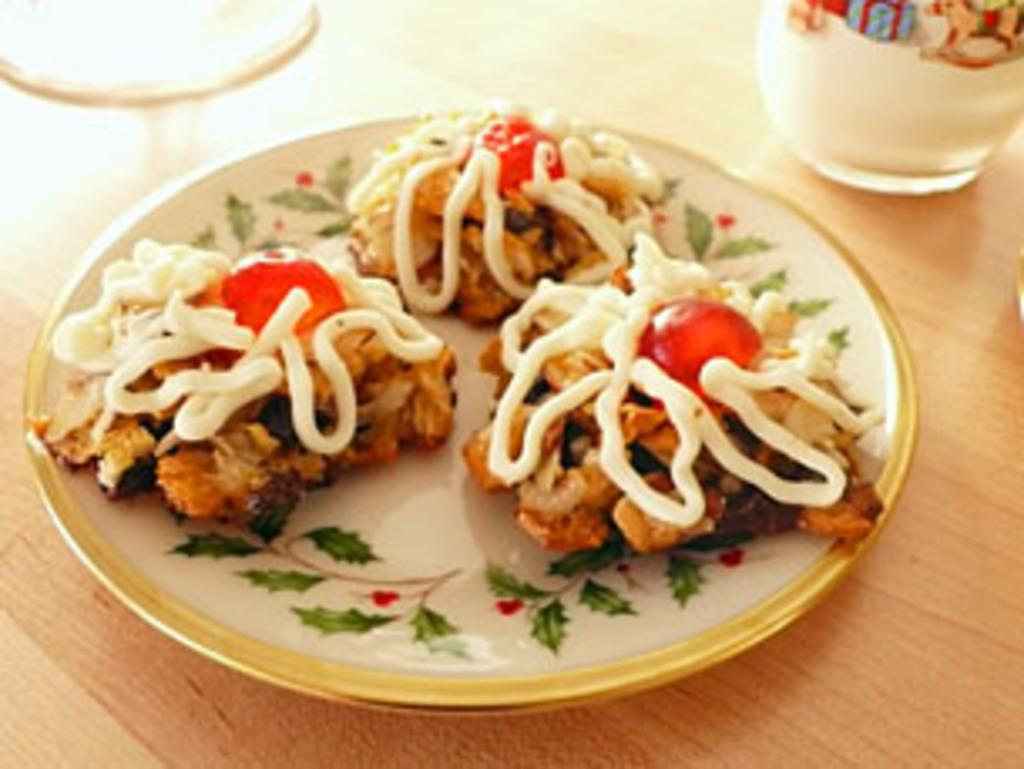What is on the plate that is visible in the image? There is food in a plate in the image. What else can be seen on the table in the image? There is a glass on the table in the image. What is the tendency of the oven in the image? There is no oven present in the image, so it is not possible to determine its tendency. 